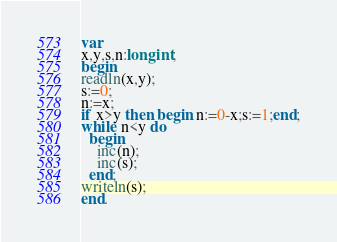<code> <loc_0><loc_0><loc_500><loc_500><_Pascal_>var
x,y,s,n:longint;
begin
readln(x,y);
s:=0;
n:=x;
if x>y then begin n:=0-x;s:=1;end;
while n<y do
  begin
    inc(n);
    inc(s);
  end;
writeln(s);
end.</code> 